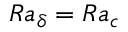<formula> <loc_0><loc_0><loc_500><loc_500>R a _ { \delta } = R a _ { c }</formula> 